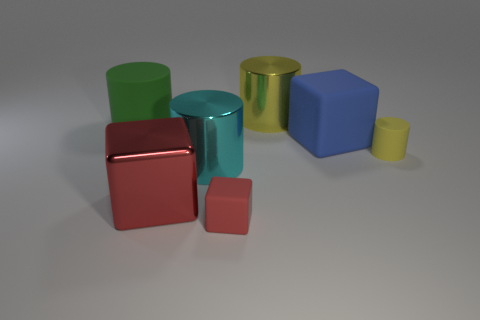Are there any large red cylinders made of the same material as the small yellow object?
Your response must be concise. No. What material is the yellow cylinder that is the same size as the green object?
Ensure brevity in your answer.  Metal. Are there fewer tiny rubber cylinders that are behind the tiny yellow rubber cylinder than big cubes right of the large yellow thing?
Provide a short and direct response. Yes. There is a object that is to the left of the cyan metal object and behind the small yellow rubber cylinder; what shape is it?
Offer a terse response. Cylinder. How many other shiny things have the same shape as the big cyan metal thing?
Ensure brevity in your answer.  1. What size is the red object that is the same material as the small cylinder?
Offer a terse response. Small. Is the number of blue matte cubes greater than the number of objects?
Ensure brevity in your answer.  No. There is a large metal cylinder that is in front of the big green thing; what color is it?
Give a very brief answer. Cyan. There is a matte object that is both in front of the big blue matte cube and to the left of the yellow rubber object; what is its size?
Provide a succinct answer. Small. What number of red matte objects have the same size as the green cylinder?
Your response must be concise. 0. 